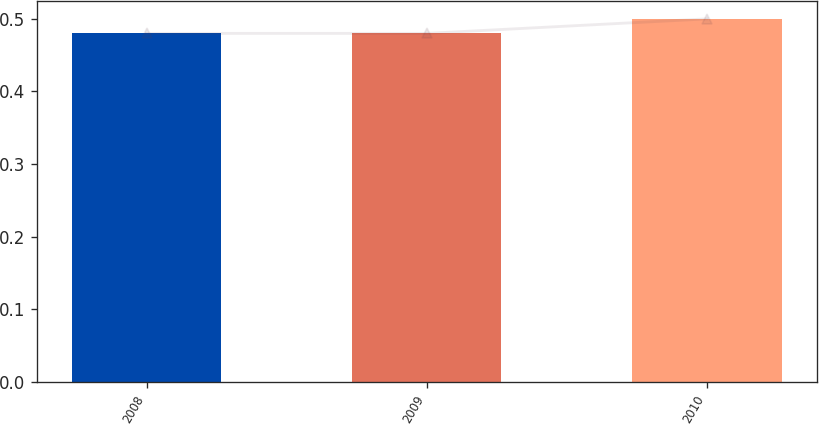Convert chart. <chart><loc_0><loc_0><loc_500><loc_500><bar_chart><fcel>2008<fcel>2009<fcel>2010<nl><fcel>0.48<fcel>0.48<fcel>0.5<nl></chart> 